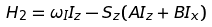<formula> <loc_0><loc_0><loc_500><loc_500>H _ { 2 } = \omega _ { I } I _ { z } - S _ { z } ( A I _ { z } + B I _ { x } )</formula> 